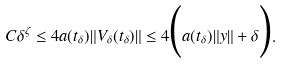<formula> <loc_0><loc_0><loc_500><loc_500>C \delta ^ { \zeta } \leq 4 a ( t _ { \delta } ) \| V _ { \delta } ( t _ { \delta } ) \| \leq 4 \Big { ( } a ( t _ { \delta } ) \| y \| + \delta \Big { ) } .</formula> 